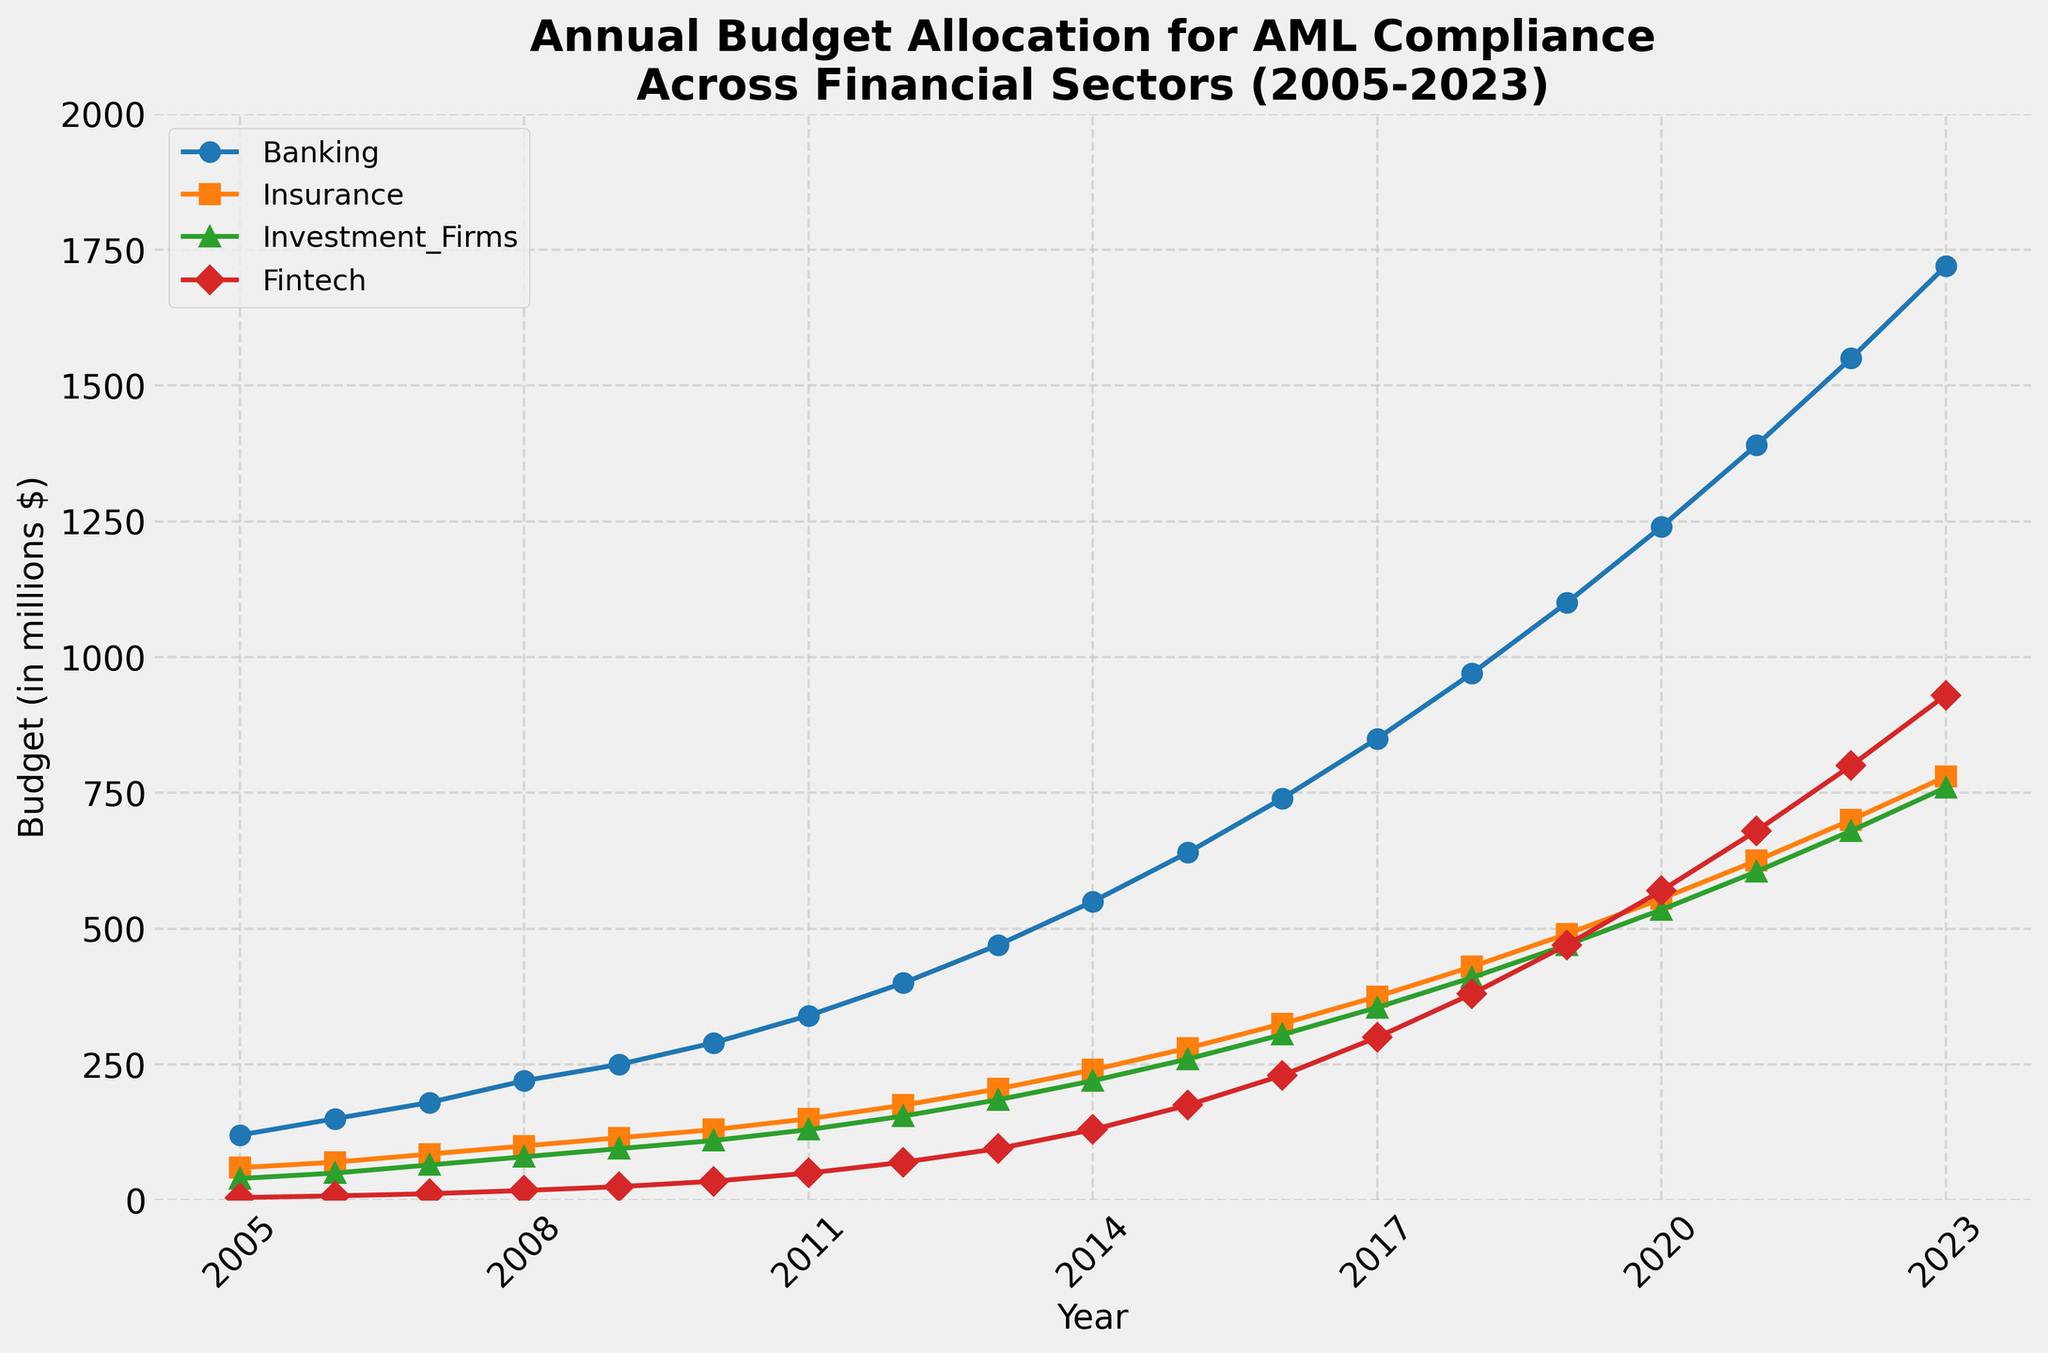What is the pattern for the annual budget allocation for AML compliance in the Banking sector from 2005 to 2023? The budget for the Banking sector consistently increases every year from 2005 to 2023, starting at $120 million in 2005 and rising to $1720 million in 2023.
Answer: The budget consistently increases Which sector had the highest budget allocation for AML compliance in 2015? By observing the lines and markers for 2015, the Banking sector had the highest budget allocation, followed by Insurance, then Investment Firms, and finally Fintech.
Answer: Banking In which year did Fintech's budget for AML compliance exceed $500 million? By tracing the red line representing Fintech, we see that the budget exceeds $500 million in 2020.
Answer: 2020 What was the total budget allocation for AML compliance across all sectors in 2010? Sum the budgets for each sector in 2010: Banking (290) + Insurance (130) + Investment_Firms (110) + Fintech (35) = 565 million dollars.
Answer: 565 million dollars How much did the budget for the Insurance sector increase between 2010 and 2020? Subtract the 2010 budget from the 2020 budget for Insurance: 555 (2020) - 130 (2010) = 425 million dollars.
Answer: 425 million dollars Which sector showed the most rapid increase in budget allocation between 2018 and 2023? By comparing the slopes of the lines between 2018 and 2023, the Fintech sector shows the most rapid increase.
Answer: Fintech What is the average annual budget allocation for AML compliance in the Investment Firms sector from 2005 to 2023? Sum the budget allocations for Investment Firms from 2005 to 2023 and divide by the number of years (19 years): (40+50+65+80+95+110+130+155+185+220+260+305+355+410+470+535+605+680+760) / 19 = 275.79 million dollars (rounded to 2 decimal places).
Answer: 275.79 million dollars (rounded) Between which consecutive years did the Banking sector see the greatest increase in its AML compliance budget? Calculate the yearly differences for the Banking sector and find the maximum difference. The greatest increase occurs between 2021 (1390) and 2022 (1550), with a difference of 160 million dollars.
Answer: 2021 to 2022 How does the budget allocation in 2023 for the Fintech sector compare to the Investment Firms sector? By looking at the endpoints of the lines for 2023, Fintech has a budget of $930 million while Investment Firms have $760 million, meaning Fintech has a higher budget.
Answer: Fintech has a higher budget 